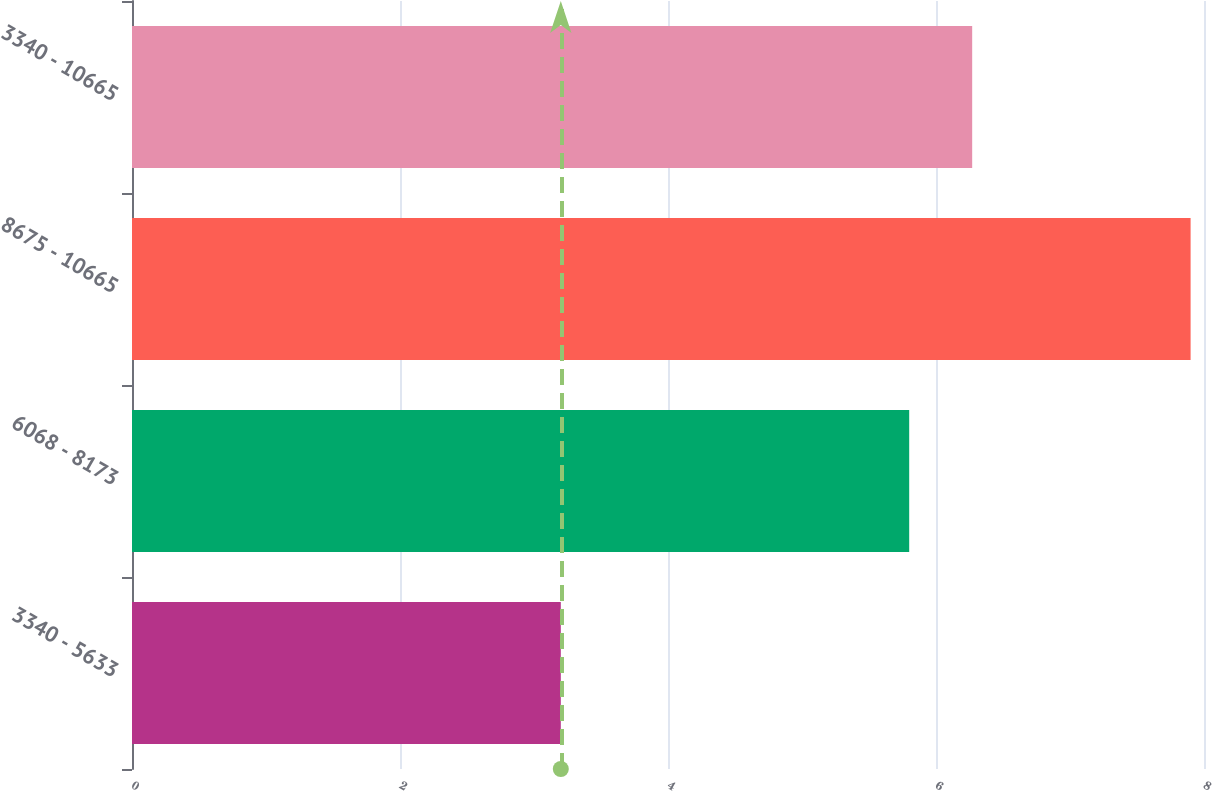<chart> <loc_0><loc_0><loc_500><loc_500><bar_chart><fcel>3340 - 5633<fcel>6068 - 8173<fcel>8675 - 10665<fcel>3340 - 10665<nl><fcel>3.2<fcel>5.8<fcel>7.9<fcel>6.27<nl></chart> 